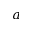<formula> <loc_0><loc_0><loc_500><loc_500>a</formula> 